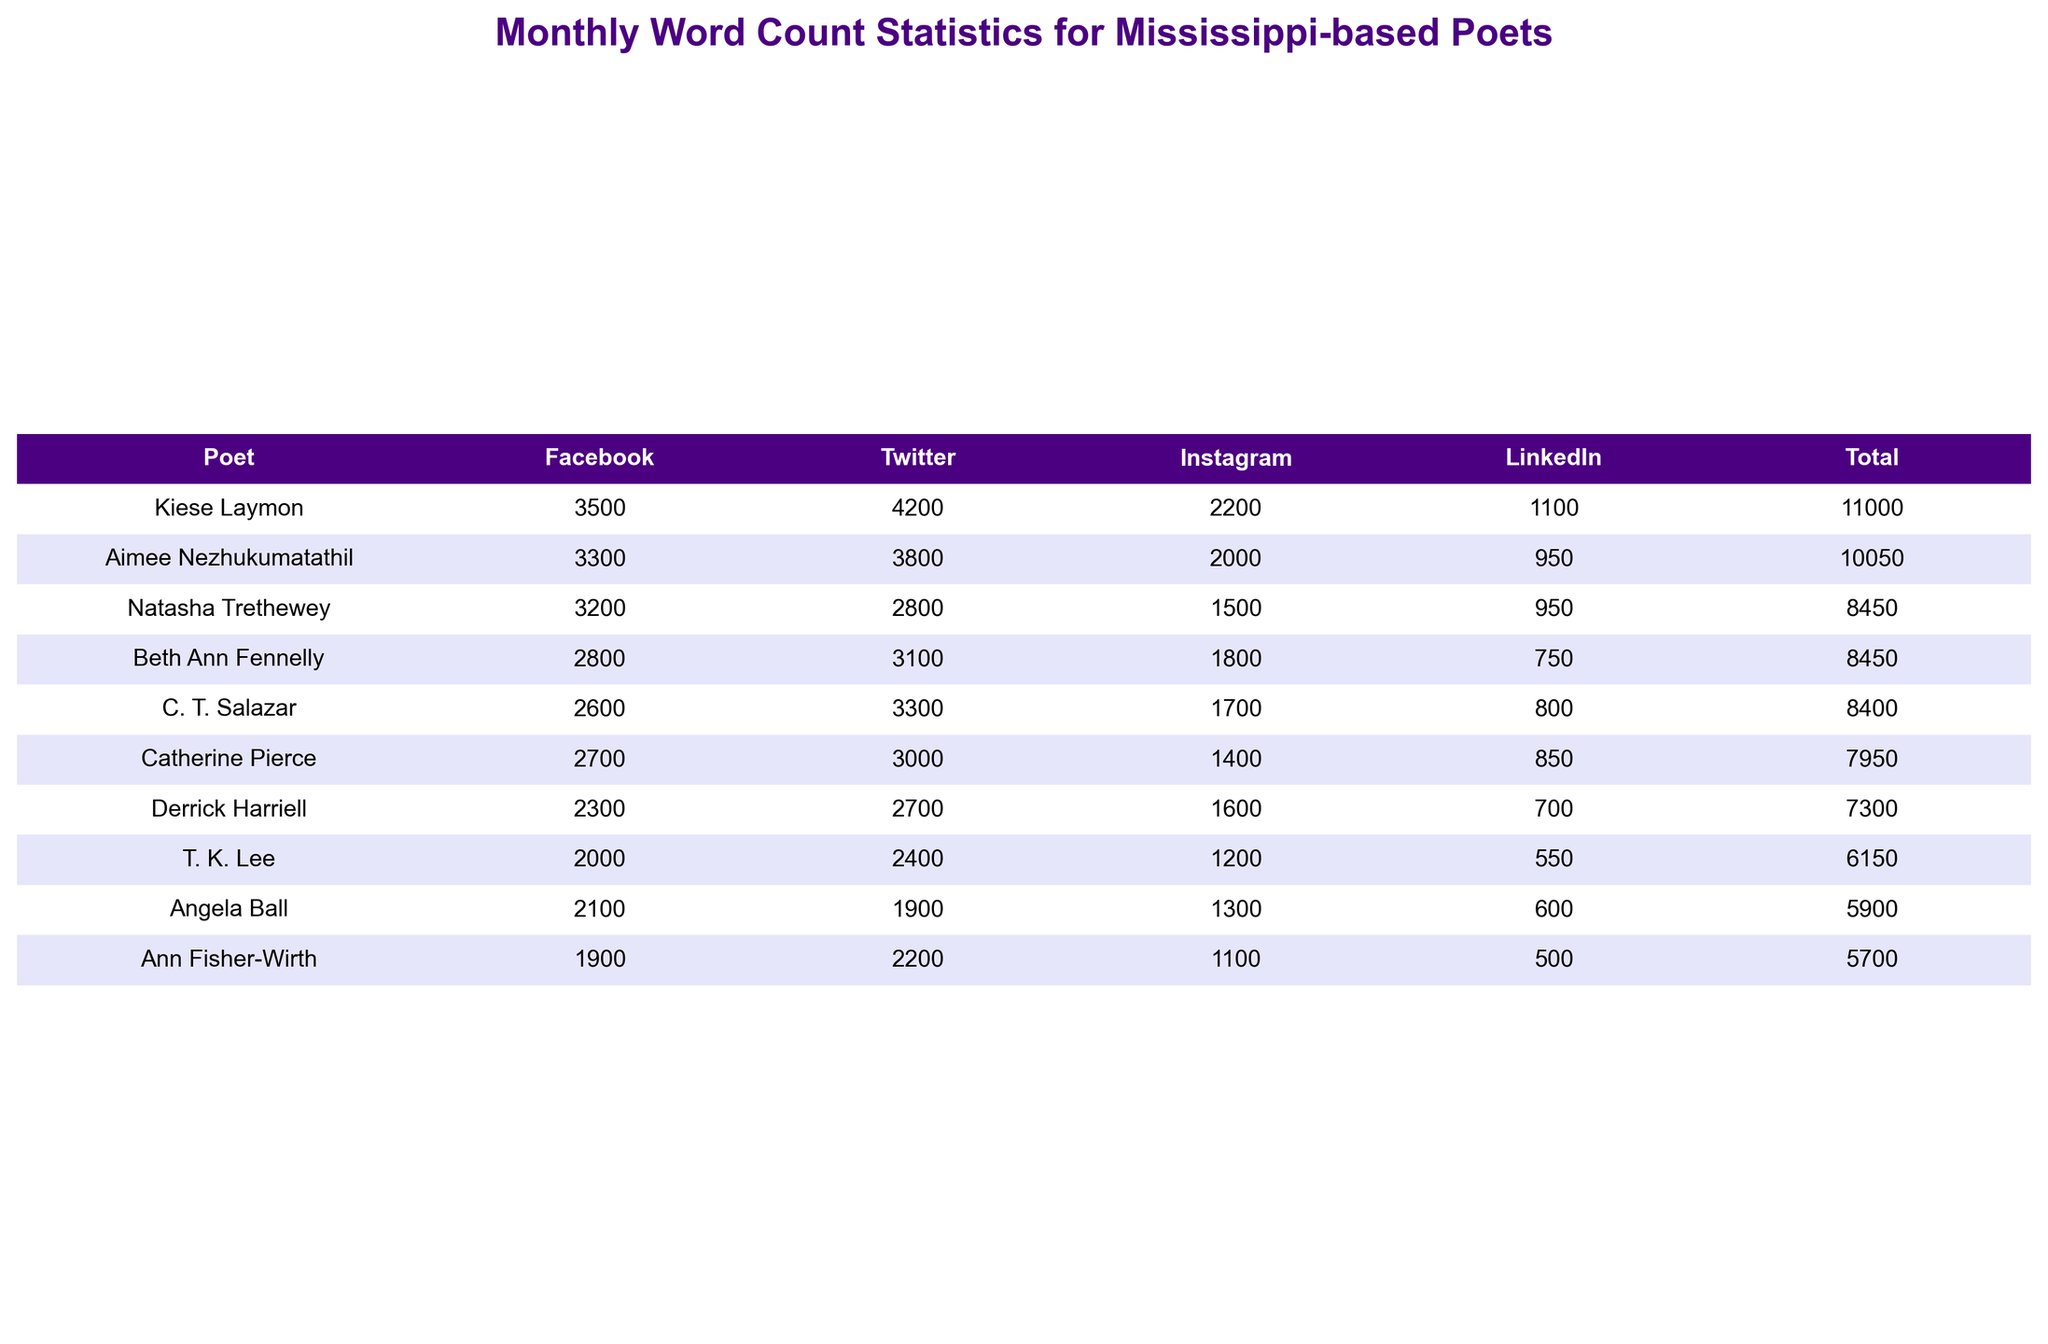What poet has the highest word count on Facebook? Looking at the Facebook column, Kiese Laymon has the highest word count with 3500 words.
Answer: Kiese Laymon What is the total word count for Ann Fisher-Wirth across all platforms? To find the total for Ann Fisher-Wirth, sum the values: 1900 (Facebook) + 2200 (Twitter) + 1100 (Instagram) + 500 (LinkedIn) = 5700.
Answer: 5700 Is it true that Angela Ball has more total words across all platforms than Derrick Harriell? Calculate the totals for both poets: Angela Ball's total is 2100 + 1900 + 1300 + 600 = 6900; Derrick Harriell's total is 2300 + 2700 + 1600 + 700 = 7300. Since 6900 < 7300, it is false.
Answer: No What is the average monthly word count for Kiese Laymon across all platforms? Kiese Laymon's word counts are: 3500 (Facebook), 4200 (Twitter), 2200 (Instagram), and 1100 (LinkedIn). The total is 3500 + 4200 + 2200 + 1100 = 11000. There are 4 platforms, so the average is 11000 / 4 = 2750.
Answer: 2750 Who has the lowest word count on Instagram? The Instagram counts show that Ann Fisher-Wirth has the lowest word count with 1100 words.
Answer: Ann Fisher-Wirth What is the difference in total word count between the poet with the highest and lowest totals? Kiese Laymon has the highest total of 11000 words, while Ann Fisher-Wirth has the lowest at 5700. The difference is 11000 - 5700 = 5300.
Answer: 5300 Which platform has the highest overall engagement (sum of word counts) among all poets? Calculating the total counts for each platform: Facebook = 3200 + 2800 + 3500 + 2100 + 2600 + 1900 + 2300 + 2700 + 3300 + 2000 = 25300, Twitter = 2800 + 3100 + 4200 + 1900 + 3300 + 2200 + 2700 + 3000 + 3800 + 2400 = 27800, Instagram = 1500 + 1800 + 2200 + 1300 + 1700 + 1100 + 1600 + 1400 + 2000 + 1200 = 15800, LinkedIn = 950 + 750 + 1100 + 600 + 800 + 500 + 700 + 850 + 950 + 550 = 5950. The highest total is from Twitter with 27800.
Answer: Twitter What is the median word count for Facebook users? The Facebook word counts, sorted, are: 1900, 2000, 2100, 2600, 2800, 3200, 3300, 3500. There are 10 values; we take the average of the 5th and 6th numbers: (2800 + 3200) / 2 = 3000.
Answer: 3000 